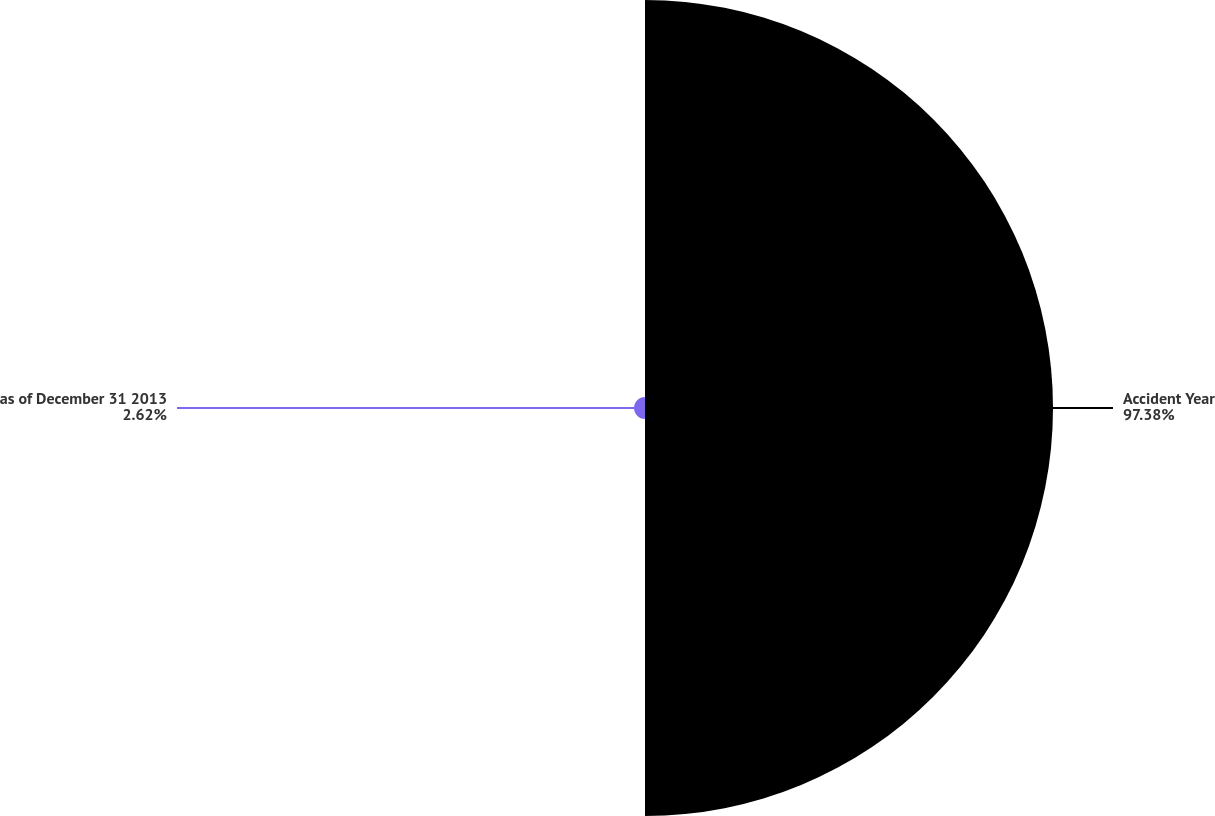<chart> <loc_0><loc_0><loc_500><loc_500><pie_chart><fcel>Accident Year<fcel>as of December 31 2013<nl><fcel>97.38%<fcel>2.62%<nl></chart> 